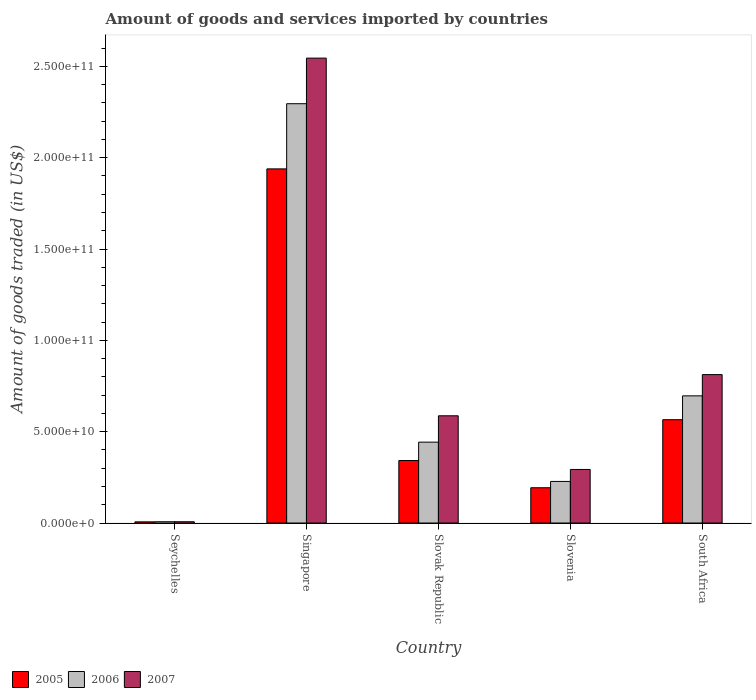How many different coloured bars are there?
Make the answer very short. 3. Are the number of bars on each tick of the X-axis equal?
Your answer should be very brief. Yes. How many bars are there on the 2nd tick from the left?
Give a very brief answer. 3. What is the label of the 4th group of bars from the left?
Make the answer very short. Slovenia. In how many cases, is the number of bars for a given country not equal to the number of legend labels?
Offer a very short reply. 0. What is the total amount of goods and services imported in 2006 in Seychelles?
Provide a succinct answer. 7.02e+08. Across all countries, what is the maximum total amount of goods and services imported in 2006?
Your answer should be very brief. 2.30e+11. Across all countries, what is the minimum total amount of goods and services imported in 2007?
Give a very brief answer. 7.02e+08. In which country was the total amount of goods and services imported in 2005 maximum?
Provide a short and direct response. Singapore. In which country was the total amount of goods and services imported in 2007 minimum?
Keep it short and to the point. Seychelles. What is the total total amount of goods and services imported in 2006 in the graph?
Offer a very short reply. 3.67e+11. What is the difference between the total amount of goods and services imported in 2007 in Seychelles and that in Slovak Republic?
Offer a very short reply. -5.80e+1. What is the difference between the total amount of goods and services imported in 2006 in Slovak Republic and the total amount of goods and services imported in 2005 in Seychelles?
Offer a very short reply. 4.36e+1. What is the average total amount of goods and services imported in 2005 per country?
Your answer should be very brief. 6.09e+1. What is the difference between the total amount of goods and services imported of/in 2006 and total amount of goods and services imported of/in 2007 in Slovak Republic?
Your answer should be compact. -1.44e+1. What is the ratio of the total amount of goods and services imported in 2005 in Singapore to that in Slovak Republic?
Give a very brief answer. 5.67. What is the difference between the highest and the second highest total amount of goods and services imported in 2007?
Your response must be concise. 1.73e+11. What is the difference between the highest and the lowest total amount of goods and services imported in 2005?
Provide a succinct answer. 1.93e+11. In how many countries, is the total amount of goods and services imported in 2007 greater than the average total amount of goods and services imported in 2007 taken over all countries?
Provide a short and direct response. 1. What does the 3rd bar from the left in Slovak Republic represents?
Provide a succinct answer. 2007. What does the 3rd bar from the right in Slovak Republic represents?
Give a very brief answer. 2005. Is it the case that in every country, the sum of the total amount of goods and services imported in 2006 and total amount of goods and services imported in 2007 is greater than the total amount of goods and services imported in 2005?
Keep it short and to the point. Yes. Are all the bars in the graph horizontal?
Your response must be concise. No. How many countries are there in the graph?
Ensure brevity in your answer.  5. What is the difference between two consecutive major ticks on the Y-axis?
Offer a very short reply. 5.00e+1. Are the values on the major ticks of Y-axis written in scientific E-notation?
Provide a succinct answer. Yes. Does the graph contain grids?
Your response must be concise. No. What is the title of the graph?
Keep it short and to the point. Amount of goods and services imported by countries. Does "1994" appear as one of the legend labels in the graph?
Provide a short and direct response. No. What is the label or title of the X-axis?
Keep it short and to the point. Country. What is the label or title of the Y-axis?
Your answer should be very brief. Amount of goods traded (in US$). What is the Amount of goods traded (in US$) in 2005 in Seychelles?
Offer a very short reply. 6.45e+08. What is the Amount of goods traded (in US$) of 2006 in Seychelles?
Keep it short and to the point. 7.02e+08. What is the Amount of goods traded (in US$) in 2007 in Seychelles?
Give a very brief answer. 7.02e+08. What is the Amount of goods traded (in US$) in 2005 in Singapore?
Offer a very short reply. 1.94e+11. What is the Amount of goods traded (in US$) of 2006 in Singapore?
Make the answer very short. 2.30e+11. What is the Amount of goods traded (in US$) of 2007 in Singapore?
Your response must be concise. 2.55e+11. What is the Amount of goods traded (in US$) of 2005 in Slovak Republic?
Your response must be concise. 3.42e+1. What is the Amount of goods traded (in US$) in 2006 in Slovak Republic?
Offer a very short reply. 4.43e+1. What is the Amount of goods traded (in US$) of 2007 in Slovak Republic?
Offer a terse response. 5.87e+1. What is the Amount of goods traded (in US$) in 2005 in Slovenia?
Give a very brief answer. 1.93e+1. What is the Amount of goods traded (in US$) in 2006 in Slovenia?
Provide a short and direct response. 2.28e+1. What is the Amount of goods traded (in US$) in 2007 in Slovenia?
Your response must be concise. 2.93e+1. What is the Amount of goods traded (in US$) in 2005 in South Africa?
Ensure brevity in your answer.  5.66e+1. What is the Amount of goods traded (in US$) in 2006 in South Africa?
Ensure brevity in your answer.  6.96e+1. What is the Amount of goods traded (in US$) of 2007 in South Africa?
Keep it short and to the point. 8.13e+1. Across all countries, what is the maximum Amount of goods traded (in US$) of 2005?
Your answer should be very brief. 1.94e+11. Across all countries, what is the maximum Amount of goods traded (in US$) in 2006?
Offer a very short reply. 2.30e+11. Across all countries, what is the maximum Amount of goods traded (in US$) of 2007?
Provide a short and direct response. 2.55e+11. Across all countries, what is the minimum Amount of goods traded (in US$) of 2005?
Provide a succinct answer. 6.45e+08. Across all countries, what is the minimum Amount of goods traded (in US$) in 2006?
Offer a very short reply. 7.02e+08. Across all countries, what is the minimum Amount of goods traded (in US$) of 2007?
Give a very brief answer. 7.02e+08. What is the total Amount of goods traded (in US$) of 2005 in the graph?
Your response must be concise. 3.05e+11. What is the total Amount of goods traded (in US$) in 2006 in the graph?
Your answer should be compact. 3.67e+11. What is the total Amount of goods traded (in US$) in 2007 in the graph?
Your answer should be compact. 4.25e+11. What is the difference between the Amount of goods traded (in US$) in 2005 in Seychelles and that in Singapore?
Offer a very short reply. -1.93e+11. What is the difference between the Amount of goods traded (in US$) in 2006 in Seychelles and that in Singapore?
Keep it short and to the point. -2.29e+11. What is the difference between the Amount of goods traded (in US$) of 2007 in Seychelles and that in Singapore?
Give a very brief answer. -2.54e+11. What is the difference between the Amount of goods traded (in US$) of 2005 in Seychelles and that in Slovak Republic?
Ensure brevity in your answer.  -3.36e+1. What is the difference between the Amount of goods traded (in US$) in 2006 in Seychelles and that in Slovak Republic?
Provide a short and direct response. -4.36e+1. What is the difference between the Amount of goods traded (in US$) in 2007 in Seychelles and that in Slovak Republic?
Ensure brevity in your answer.  -5.80e+1. What is the difference between the Amount of goods traded (in US$) in 2005 in Seychelles and that in Slovenia?
Give a very brief answer. -1.87e+1. What is the difference between the Amount of goods traded (in US$) of 2006 in Seychelles and that in Slovenia?
Make the answer very short. -2.21e+1. What is the difference between the Amount of goods traded (in US$) of 2007 in Seychelles and that in Slovenia?
Offer a very short reply. -2.86e+1. What is the difference between the Amount of goods traded (in US$) of 2005 in Seychelles and that in South Africa?
Your answer should be compact. -5.59e+1. What is the difference between the Amount of goods traded (in US$) in 2006 in Seychelles and that in South Africa?
Give a very brief answer. -6.89e+1. What is the difference between the Amount of goods traded (in US$) in 2007 in Seychelles and that in South Africa?
Offer a very short reply. -8.06e+1. What is the difference between the Amount of goods traded (in US$) of 2005 in Singapore and that in Slovak Republic?
Make the answer very short. 1.60e+11. What is the difference between the Amount of goods traded (in US$) in 2006 in Singapore and that in Slovak Republic?
Offer a terse response. 1.85e+11. What is the difference between the Amount of goods traded (in US$) of 2007 in Singapore and that in Slovak Republic?
Keep it short and to the point. 1.96e+11. What is the difference between the Amount of goods traded (in US$) of 2005 in Singapore and that in Slovenia?
Offer a terse response. 1.75e+11. What is the difference between the Amount of goods traded (in US$) of 2006 in Singapore and that in Slovenia?
Give a very brief answer. 2.07e+11. What is the difference between the Amount of goods traded (in US$) of 2007 in Singapore and that in Slovenia?
Keep it short and to the point. 2.25e+11. What is the difference between the Amount of goods traded (in US$) of 2005 in Singapore and that in South Africa?
Provide a succinct answer. 1.37e+11. What is the difference between the Amount of goods traded (in US$) of 2006 in Singapore and that in South Africa?
Give a very brief answer. 1.60e+11. What is the difference between the Amount of goods traded (in US$) in 2007 in Singapore and that in South Africa?
Offer a terse response. 1.73e+11. What is the difference between the Amount of goods traded (in US$) of 2005 in Slovak Republic and that in Slovenia?
Give a very brief answer. 1.49e+1. What is the difference between the Amount of goods traded (in US$) in 2006 in Slovak Republic and that in Slovenia?
Provide a short and direct response. 2.15e+1. What is the difference between the Amount of goods traded (in US$) of 2007 in Slovak Republic and that in Slovenia?
Offer a very short reply. 2.94e+1. What is the difference between the Amount of goods traded (in US$) of 2005 in Slovak Republic and that in South Africa?
Your answer should be very brief. -2.24e+1. What is the difference between the Amount of goods traded (in US$) of 2006 in Slovak Republic and that in South Africa?
Your response must be concise. -2.53e+1. What is the difference between the Amount of goods traded (in US$) in 2007 in Slovak Republic and that in South Africa?
Provide a short and direct response. -2.25e+1. What is the difference between the Amount of goods traded (in US$) of 2005 in Slovenia and that in South Africa?
Ensure brevity in your answer.  -3.72e+1. What is the difference between the Amount of goods traded (in US$) in 2006 in Slovenia and that in South Africa?
Your response must be concise. -4.69e+1. What is the difference between the Amount of goods traded (in US$) in 2007 in Slovenia and that in South Africa?
Your answer should be compact. -5.19e+1. What is the difference between the Amount of goods traded (in US$) in 2005 in Seychelles and the Amount of goods traded (in US$) in 2006 in Singapore?
Ensure brevity in your answer.  -2.29e+11. What is the difference between the Amount of goods traded (in US$) of 2005 in Seychelles and the Amount of goods traded (in US$) of 2007 in Singapore?
Provide a succinct answer. -2.54e+11. What is the difference between the Amount of goods traded (in US$) of 2006 in Seychelles and the Amount of goods traded (in US$) of 2007 in Singapore?
Offer a very short reply. -2.54e+11. What is the difference between the Amount of goods traded (in US$) in 2005 in Seychelles and the Amount of goods traded (in US$) in 2006 in Slovak Republic?
Make the answer very short. -4.36e+1. What is the difference between the Amount of goods traded (in US$) in 2005 in Seychelles and the Amount of goods traded (in US$) in 2007 in Slovak Republic?
Your answer should be compact. -5.81e+1. What is the difference between the Amount of goods traded (in US$) of 2006 in Seychelles and the Amount of goods traded (in US$) of 2007 in Slovak Republic?
Keep it short and to the point. -5.80e+1. What is the difference between the Amount of goods traded (in US$) in 2005 in Seychelles and the Amount of goods traded (in US$) in 2006 in Slovenia?
Provide a succinct answer. -2.21e+1. What is the difference between the Amount of goods traded (in US$) in 2005 in Seychelles and the Amount of goods traded (in US$) in 2007 in Slovenia?
Offer a terse response. -2.87e+1. What is the difference between the Amount of goods traded (in US$) in 2006 in Seychelles and the Amount of goods traded (in US$) in 2007 in Slovenia?
Make the answer very short. -2.86e+1. What is the difference between the Amount of goods traded (in US$) in 2005 in Seychelles and the Amount of goods traded (in US$) in 2006 in South Africa?
Offer a very short reply. -6.90e+1. What is the difference between the Amount of goods traded (in US$) of 2005 in Seychelles and the Amount of goods traded (in US$) of 2007 in South Africa?
Ensure brevity in your answer.  -8.06e+1. What is the difference between the Amount of goods traded (in US$) in 2006 in Seychelles and the Amount of goods traded (in US$) in 2007 in South Africa?
Your answer should be very brief. -8.06e+1. What is the difference between the Amount of goods traded (in US$) in 2005 in Singapore and the Amount of goods traded (in US$) in 2006 in Slovak Republic?
Make the answer very short. 1.50e+11. What is the difference between the Amount of goods traded (in US$) of 2005 in Singapore and the Amount of goods traded (in US$) of 2007 in Slovak Republic?
Provide a succinct answer. 1.35e+11. What is the difference between the Amount of goods traded (in US$) of 2006 in Singapore and the Amount of goods traded (in US$) of 2007 in Slovak Republic?
Your response must be concise. 1.71e+11. What is the difference between the Amount of goods traded (in US$) of 2005 in Singapore and the Amount of goods traded (in US$) of 2006 in Slovenia?
Provide a short and direct response. 1.71e+11. What is the difference between the Amount of goods traded (in US$) of 2005 in Singapore and the Amount of goods traded (in US$) of 2007 in Slovenia?
Provide a succinct answer. 1.65e+11. What is the difference between the Amount of goods traded (in US$) in 2006 in Singapore and the Amount of goods traded (in US$) in 2007 in Slovenia?
Give a very brief answer. 2.00e+11. What is the difference between the Amount of goods traded (in US$) of 2005 in Singapore and the Amount of goods traded (in US$) of 2006 in South Africa?
Provide a short and direct response. 1.24e+11. What is the difference between the Amount of goods traded (in US$) in 2005 in Singapore and the Amount of goods traded (in US$) in 2007 in South Africa?
Provide a succinct answer. 1.13e+11. What is the difference between the Amount of goods traded (in US$) of 2006 in Singapore and the Amount of goods traded (in US$) of 2007 in South Africa?
Offer a terse response. 1.48e+11. What is the difference between the Amount of goods traded (in US$) in 2005 in Slovak Republic and the Amount of goods traded (in US$) in 2006 in Slovenia?
Give a very brief answer. 1.14e+1. What is the difference between the Amount of goods traded (in US$) in 2005 in Slovak Republic and the Amount of goods traded (in US$) in 2007 in Slovenia?
Provide a short and direct response. 4.88e+09. What is the difference between the Amount of goods traded (in US$) of 2006 in Slovak Republic and the Amount of goods traded (in US$) of 2007 in Slovenia?
Keep it short and to the point. 1.50e+1. What is the difference between the Amount of goods traded (in US$) of 2005 in Slovak Republic and the Amount of goods traded (in US$) of 2006 in South Africa?
Ensure brevity in your answer.  -3.54e+1. What is the difference between the Amount of goods traded (in US$) of 2005 in Slovak Republic and the Amount of goods traded (in US$) of 2007 in South Africa?
Provide a succinct answer. -4.70e+1. What is the difference between the Amount of goods traded (in US$) in 2006 in Slovak Republic and the Amount of goods traded (in US$) in 2007 in South Africa?
Provide a short and direct response. -3.70e+1. What is the difference between the Amount of goods traded (in US$) of 2005 in Slovenia and the Amount of goods traded (in US$) of 2006 in South Africa?
Offer a very short reply. -5.03e+1. What is the difference between the Amount of goods traded (in US$) in 2005 in Slovenia and the Amount of goods traded (in US$) in 2007 in South Africa?
Offer a very short reply. -6.19e+1. What is the difference between the Amount of goods traded (in US$) of 2006 in Slovenia and the Amount of goods traded (in US$) of 2007 in South Africa?
Your response must be concise. -5.85e+1. What is the average Amount of goods traded (in US$) of 2005 per country?
Provide a succinct answer. 6.09e+1. What is the average Amount of goods traded (in US$) of 2006 per country?
Ensure brevity in your answer.  7.34e+1. What is the average Amount of goods traded (in US$) of 2007 per country?
Ensure brevity in your answer.  8.49e+1. What is the difference between the Amount of goods traded (in US$) of 2005 and Amount of goods traded (in US$) of 2006 in Seychelles?
Offer a terse response. -5.72e+07. What is the difference between the Amount of goods traded (in US$) of 2005 and Amount of goods traded (in US$) of 2007 in Seychelles?
Provide a succinct answer. -5.73e+07. What is the difference between the Amount of goods traded (in US$) in 2006 and Amount of goods traded (in US$) in 2007 in Seychelles?
Your answer should be compact. -1.25e+05. What is the difference between the Amount of goods traded (in US$) of 2005 and Amount of goods traded (in US$) of 2006 in Singapore?
Offer a very short reply. -3.57e+1. What is the difference between the Amount of goods traded (in US$) in 2005 and Amount of goods traded (in US$) in 2007 in Singapore?
Offer a terse response. -6.06e+1. What is the difference between the Amount of goods traded (in US$) in 2006 and Amount of goods traded (in US$) in 2007 in Singapore?
Your response must be concise. -2.50e+1. What is the difference between the Amount of goods traded (in US$) in 2005 and Amount of goods traded (in US$) in 2006 in Slovak Republic?
Make the answer very short. -1.01e+1. What is the difference between the Amount of goods traded (in US$) in 2005 and Amount of goods traded (in US$) in 2007 in Slovak Republic?
Ensure brevity in your answer.  -2.45e+1. What is the difference between the Amount of goods traded (in US$) in 2006 and Amount of goods traded (in US$) in 2007 in Slovak Republic?
Your response must be concise. -1.44e+1. What is the difference between the Amount of goods traded (in US$) in 2005 and Amount of goods traded (in US$) in 2006 in Slovenia?
Keep it short and to the point. -3.45e+09. What is the difference between the Amount of goods traded (in US$) of 2005 and Amount of goods traded (in US$) of 2007 in Slovenia?
Make the answer very short. -1.00e+1. What is the difference between the Amount of goods traded (in US$) in 2006 and Amount of goods traded (in US$) in 2007 in Slovenia?
Keep it short and to the point. -6.56e+09. What is the difference between the Amount of goods traded (in US$) in 2005 and Amount of goods traded (in US$) in 2006 in South Africa?
Give a very brief answer. -1.31e+1. What is the difference between the Amount of goods traded (in US$) of 2005 and Amount of goods traded (in US$) of 2007 in South Africa?
Your response must be concise. -2.47e+1. What is the difference between the Amount of goods traded (in US$) of 2006 and Amount of goods traded (in US$) of 2007 in South Africa?
Your response must be concise. -1.16e+1. What is the ratio of the Amount of goods traded (in US$) in 2005 in Seychelles to that in Singapore?
Keep it short and to the point. 0. What is the ratio of the Amount of goods traded (in US$) in 2006 in Seychelles to that in Singapore?
Your answer should be compact. 0. What is the ratio of the Amount of goods traded (in US$) in 2007 in Seychelles to that in Singapore?
Make the answer very short. 0. What is the ratio of the Amount of goods traded (in US$) in 2005 in Seychelles to that in Slovak Republic?
Keep it short and to the point. 0.02. What is the ratio of the Amount of goods traded (in US$) of 2006 in Seychelles to that in Slovak Republic?
Give a very brief answer. 0.02. What is the ratio of the Amount of goods traded (in US$) of 2007 in Seychelles to that in Slovak Republic?
Give a very brief answer. 0.01. What is the ratio of the Amount of goods traded (in US$) in 2005 in Seychelles to that in Slovenia?
Keep it short and to the point. 0.03. What is the ratio of the Amount of goods traded (in US$) in 2006 in Seychelles to that in Slovenia?
Your response must be concise. 0.03. What is the ratio of the Amount of goods traded (in US$) of 2007 in Seychelles to that in Slovenia?
Offer a terse response. 0.02. What is the ratio of the Amount of goods traded (in US$) of 2005 in Seychelles to that in South Africa?
Offer a terse response. 0.01. What is the ratio of the Amount of goods traded (in US$) of 2006 in Seychelles to that in South Africa?
Give a very brief answer. 0.01. What is the ratio of the Amount of goods traded (in US$) of 2007 in Seychelles to that in South Africa?
Your answer should be compact. 0.01. What is the ratio of the Amount of goods traded (in US$) in 2005 in Singapore to that in Slovak Republic?
Make the answer very short. 5.67. What is the ratio of the Amount of goods traded (in US$) in 2006 in Singapore to that in Slovak Republic?
Provide a succinct answer. 5.18. What is the ratio of the Amount of goods traded (in US$) of 2007 in Singapore to that in Slovak Republic?
Provide a succinct answer. 4.34. What is the ratio of the Amount of goods traded (in US$) of 2005 in Singapore to that in Slovenia?
Make the answer very short. 10.03. What is the ratio of the Amount of goods traded (in US$) of 2006 in Singapore to that in Slovenia?
Make the answer very short. 10.08. What is the ratio of the Amount of goods traded (in US$) of 2007 in Singapore to that in Slovenia?
Provide a succinct answer. 8.68. What is the ratio of the Amount of goods traded (in US$) in 2005 in Singapore to that in South Africa?
Your response must be concise. 3.43. What is the ratio of the Amount of goods traded (in US$) of 2006 in Singapore to that in South Africa?
Offer a terse response. 3.3. What is the ratio of the Amount of goods traded (in US$) in 2007 in Singapore to that in South Africa?
Provide a short and direct response. 3.13. What is the ratio of the Amount of goods traded (in US$) in 2005 in Slovak Republic to that in Slovenia?
Ensure brevity in your answer.  1.77. What is the ratio of the Amount of goods traded (in US$) of 2006 in Slovak Republic to that in Slovenia?
Offer a terse response. 1.94. What is the ratio of the Amount of goods traded (in US$) of 2007 in Slovak Republic to that in Slovenia?
Keep it short and to the point. 2. What is the ratio of the Amount of goods traded (in US$) in 2005 in Slovak Republic to that in South Africa?
Give a very brief answer. 0.6. What is the ratio of the Amount of goods traded (in US$) in 2006 in Slovak Republic to that in South Africa?
Make the answer very short. 0.64. What is the ratio of the Amount of goods traded (in US$) in 2007 in Slovak Republic to that in South Africa?
Your response must be concise. 0.72. What is the ratio of the Amount of goods traded (in US$) in 2005 in Slovenia to that in South Africa?
Ensure brevity in your answer.  0.34. What is the ratio of the Amount of goods traded (in US$) of 2006 in Slovenia to that in South Africa?
Your response must be concise. 0.33. What is the ratio of the Amount of goods traded (in US$) in 2007 in Slovenia to that in South Africa?
Give a very brief answer. 0.36. What is the difference between the highest and the second highest Amount of goods traded (in US$) of 2005?
Your answer should be compact. 1.37e+11. What is the difference between the highest and the second highest Amount of goods traded (in US$) in 2006?
Give a very brief answer. 1.60e+11. What is the difference between the highest and the second highest Amount of goods traded (in US$) of 2007?
Provide a succinct answer. 1.73e+11. What is the difference between the highest and the lowest Amount of goods traded (in US$) of 2005?
Provide a short and direct response. 1.93e+11. What is the difference between the highest and the lowest Amount of goods traded (in US$) of 2006?
Provide a short and direct response. 2.29e+11. What is the difference between the highest and the lowest Amount of goods traded (in US$) in 2007?
Your response must be concise. 2.54e+11. 